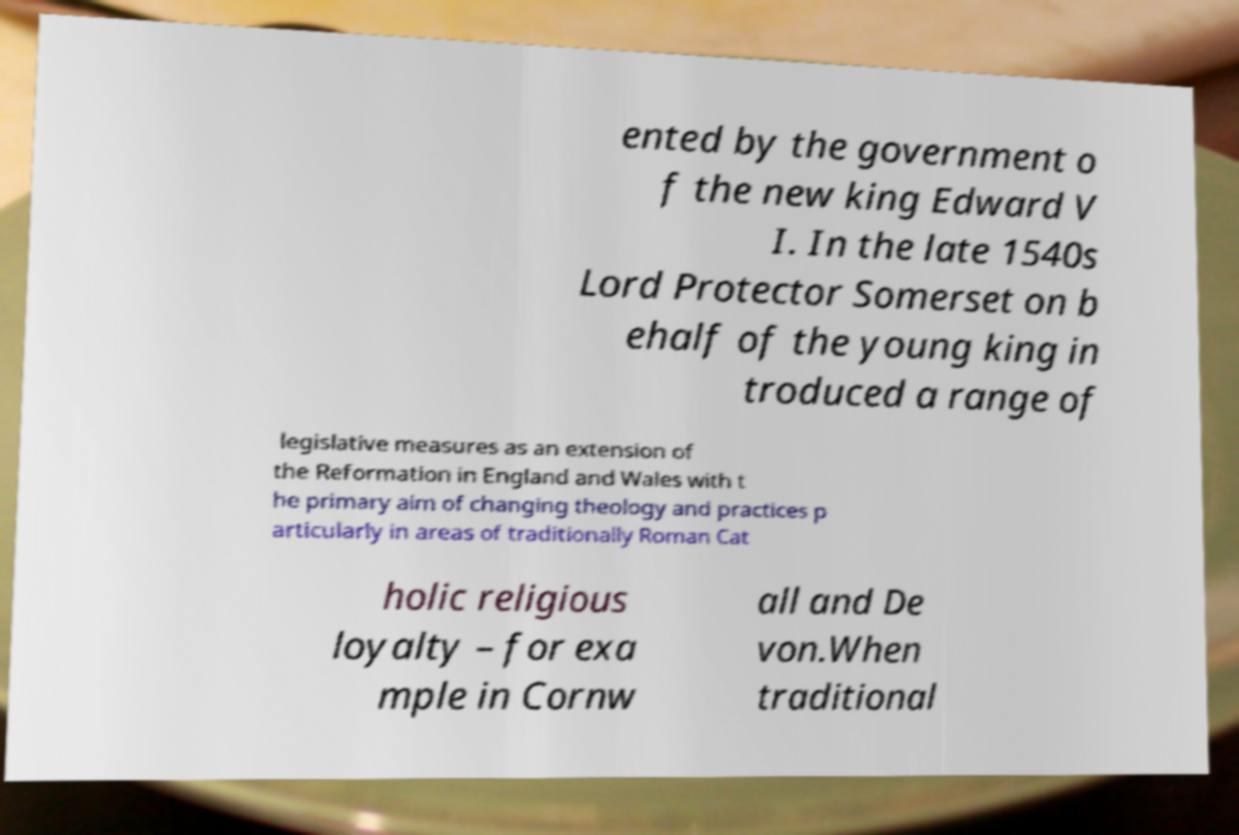There's text embedded in this image that I need extracted. Can you transcribe it verbatim? ented by the government o f the new king Edward V I. In the late 1540s Lord Protector Somerset on b ehalf of the young king in troduced a range of legislative measures as an extension of the Reformation in England and Wales with t he primary aim of changing theology and practices p articularly in areas of traditionally Roman Cat holic religious loyalty – for exa mple in Cornw all and De von.When traditional 